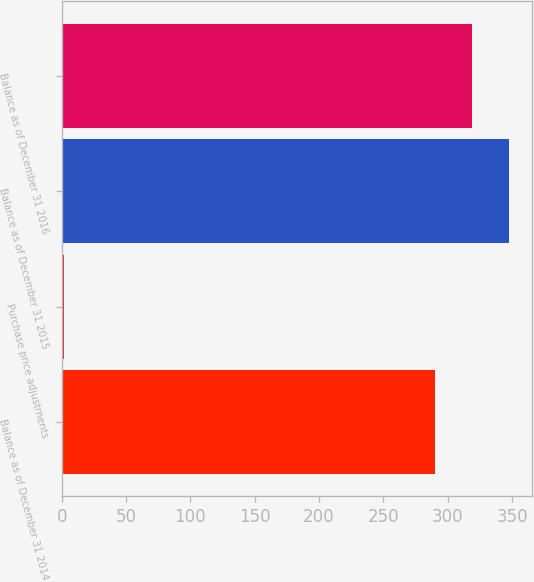Convert chart. <chart><loc_0><loc_0><loc_500><loc_500><bar_chart><fcel>Balance as of December 31 2014<fcel>Purchase price adjustments<fcel>Balance as of December 31 2015<fcel>Balance as of December 31 2016<nl><fcel>290<fcel>2<fcel>348<fcel>319<nl></chart> 